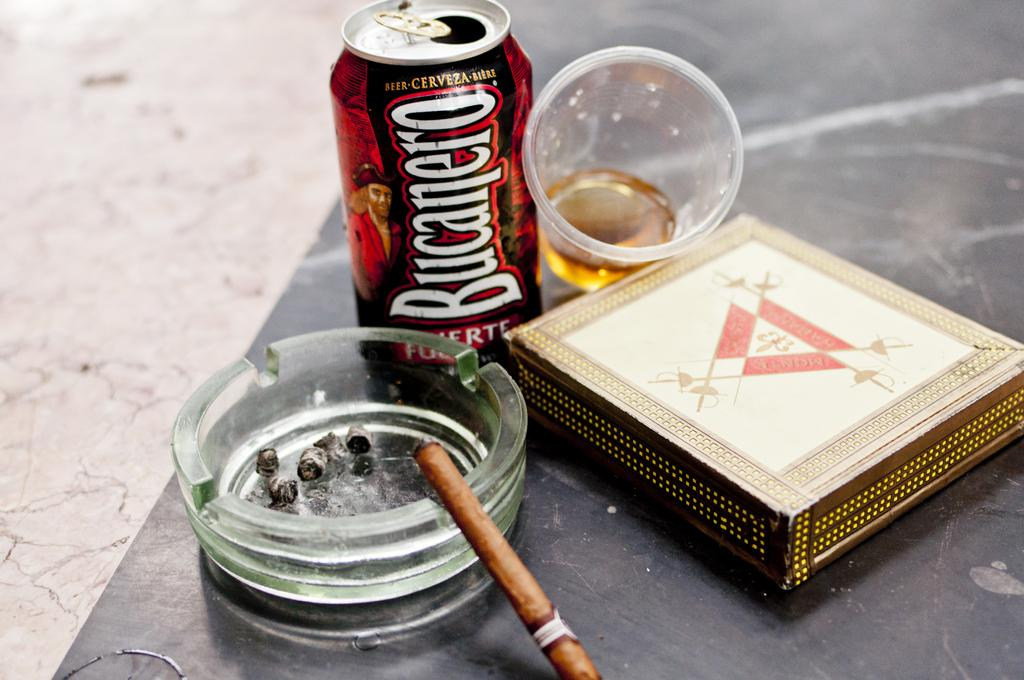<image>
Write a terse but informative summary of the picture. A can of Bucanero Beer is next to and ashtray on a table. 